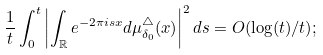<formula> <loc_0><loc_0><loc_500><loc_500>\frac { 1 } { t } \int _ { 0 } ^ { t } \left | \int _ { \mathbb { R } } e ^ { - 2 \pi i s x } d \mu _ { \delta _ { 0 } } ^ { \triangle } ( x ) \right | ^ { 2 } d s = O ( \log ( t ) / t ) ;</formula> 